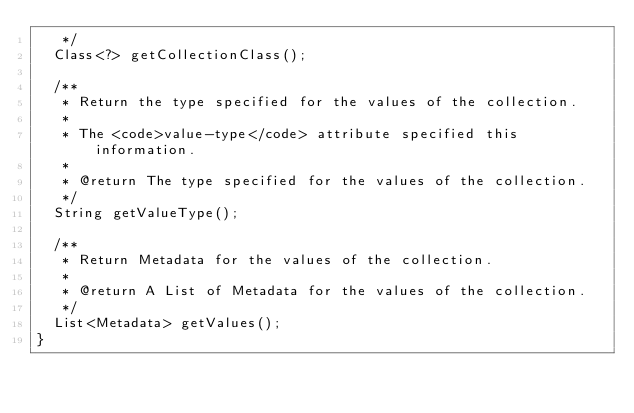<code> <loc_0><loc_0><loc_500><loc_500><_Java_>	 */
	Class<?> getCollectionClass();

	/**
	 * Return the type specified for the values of the collection.
	 * 
	 * The <code>value-type</code> attribute specified this information.
	 * 
	 * @return The type specified for the values of the collection.
	 */
	String getValueType();

	/**
	 * Return Metadata for the values of the collection.
	 * 
	 * @return A List of Metadata for the values of the collection.
	 */
	List<Metadata> getValues();
}
</code> 